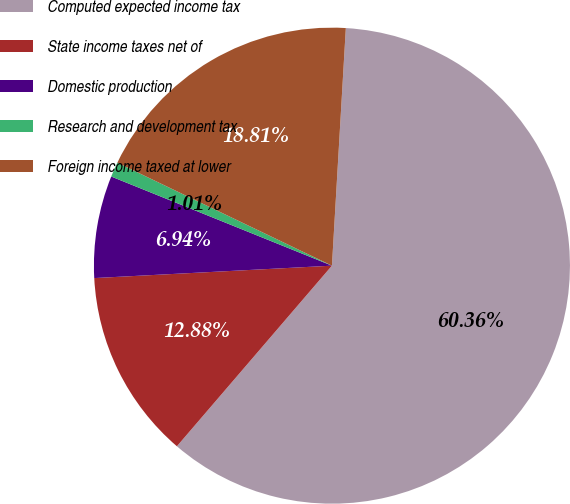Convert chart. <chart><loc_0><loc_0><loc_500><loc_500><pie_chart><fcel>Computed expected income tax<fcel>State income taxes net of<fcel>Domestic production<fcel>Research and development tax<fcel>Foreign income taxed at lower<nl><fcel>60.36%<fcel>12.88%<fcel>6.94%<fcel>1.01%<fcel>18.81%<nl></chart> 